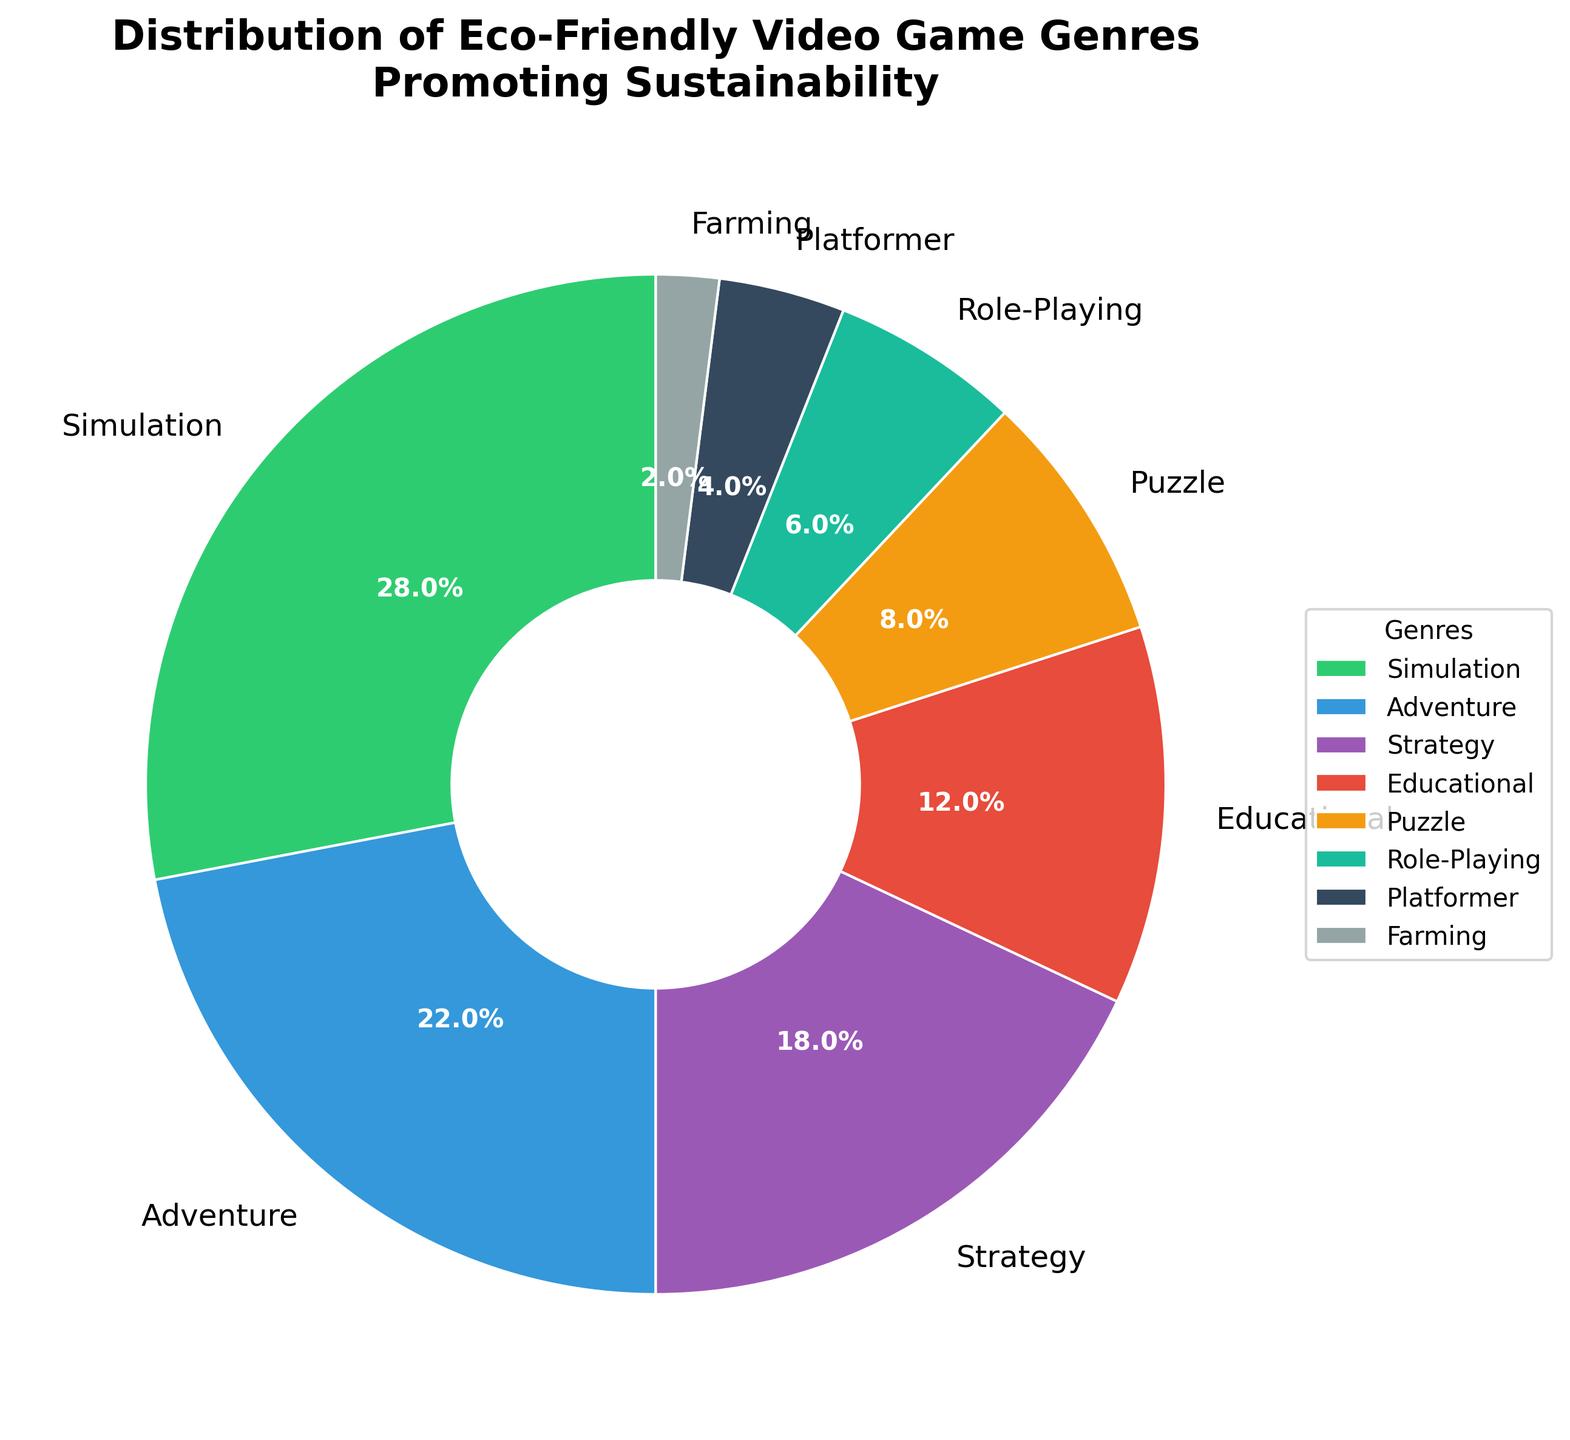What genre has the highest percentage in the distribution? The largest slice in the pie chart represents the Simulation genre with 28%.
Answer: Simulation Which genre has a smaller share, Role-Playing or Platformer? By comparing the slices, Role-Playing has 6%, while Platformer has 4%, making Platformer smaller.
Answer: Platformer What is the combined percentage of the top three genres? Adding the percentages of Simulation (28%), Adventure (22%), and Strategy (18%) gives 28 + 22 + 18 = 68%.
Answer: 68% How does the percentage of Educational games compare to Puzzle games? The slice representing Educational games is 12%, which is larger than Puzzle games at 8%.
Answer: Educational is larger Which genre is represented by the green color in the pie chart? The Simulation genre is represented by the green slice in the pie chart.
Answer: Simulation What is the difference in percentage between Strategy and Adventure genres? Adventure has 22% and Strategy has 18%, resulting in a difference of 22 - 18 = 4%.
Answer: 4% What is the total percentage of genres that each contribute less than 10%? Summing the percentages of Puzzle (8%), Role-Playing (6%), Platformer (4%), and Farming (2%) results in 8 + 6 + 4 + 2 = 20%.
Answer: 20% If you combine the percentage of Puzzle and Farming genres, is it greater than Role-Playing genre? Adding Puzzle (8%) and Farming (2%) gives 10%, which is greater than Role-Playing's 6%.
Answer: Yes What is the least represented genre in the distribution? The Farming genre has the smallest slice in the pie chart with 2%.
Answer: Farming If you add the percentages of Adventure and Educational genres, do they surpass Simulation? Summing Adventure (22%) and Educational (12%) gives 22 + 12 = 34%, which is greater than Simulation's 28%.
Answer: Yes 